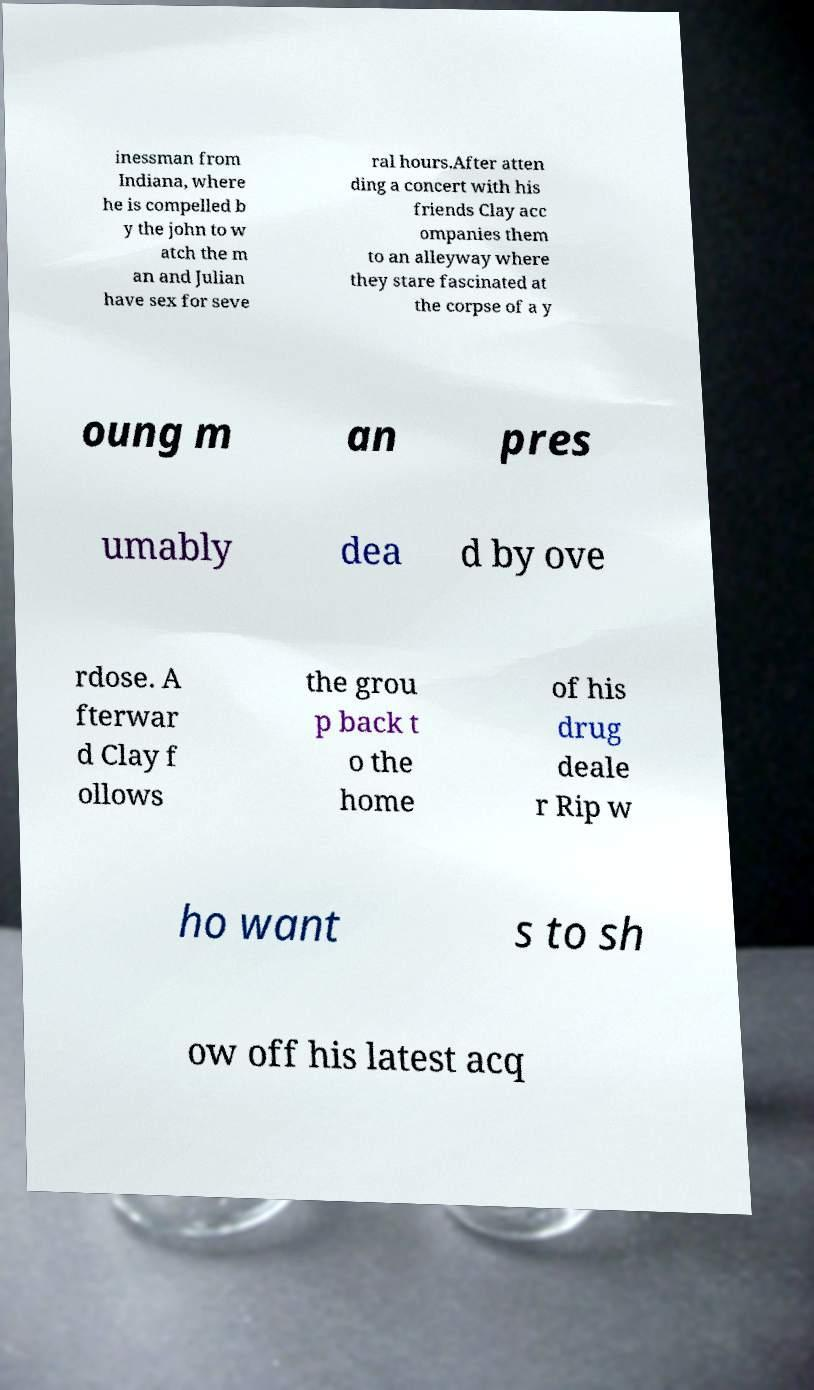For documentation purposes, I need the text within this image transcribed. Could you provide that? inessman from Indiana, where he is compelled b y the john to w atch the m an and Julian have sex for seve ral hours.After atten ding a concert with his friends Clay acc ompanies them to an alleyway where they stare fascinated at the corpse of a y oung m an pres umably dea d by ove rdose. A fterwar d Clay f ollows the grou p back t o the home of his drug deale r Rip w ho want s to sh ow off his latest acq 